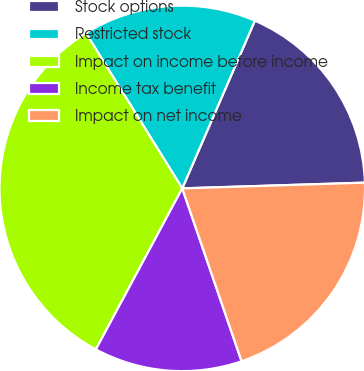<chart> <loc_0><loc_0><loc_500><loc_500><pie_chart><fcel>Stock options<fcel>Restricted stock<fcel>Impact on income before income<fcel>Income tax benefit<fcel>Impact on net income<nl><fcel>18.0%<fcel>15.34%<fcel>33.33%<fcel>13.1%<fcel>20.24%<nl></chart> 